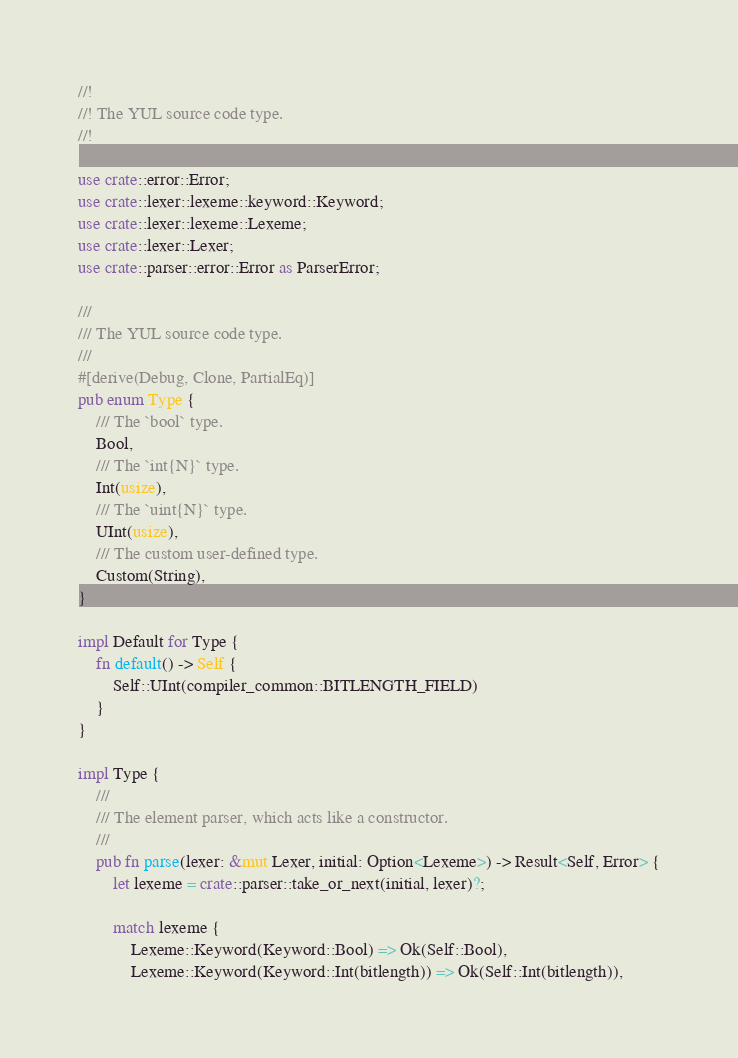<code> <loc_0><loc_0><loc_500><loc_500><_Rust_>//!
//! The YUL source code type.
//!

use crate::error::Error;
use crate::lexer::lexeme::keyword::Keyword;
use crate::lexer::lexeme::Lexeme;
use crate::lexer::Lexer;
use crate::parser::error::Error as ParserError;

///
/// The YUL source code type.
///
#[derive(Debug, Clone, PartialEq)]
pub enum Type {
    /// The `bool` type.
    Bool,
    /// The `int{N}` type.
    Int(usize),
    /// The `uint{N}` type.
    UInt(usize),
    /// The custom user-defined type.
    Custom(String),
}

impl Default for Type {
    fn default() -> Self {
        Self::UInt(compiler_common::BITLENGTH_FIELD)
    }
}

impl Type {
    ///
    /// The element parser, which acts like a constructor.
    ///
    pub fn parse(lexer: &mut Lexer, initial: Option<Lexeme>) -> Result<Self, Error> {
        let lexeme = crate::parser::take_or_next(initial, lexer)?;

        match lexeme {
            Lexeme::Keyword(Keyword::Bool) => Ok(Self::Bool),
            Lexeme::Keyword(Keyword::Int(bitlength)) => Ok(Self::Int(bitlength)),</code> 